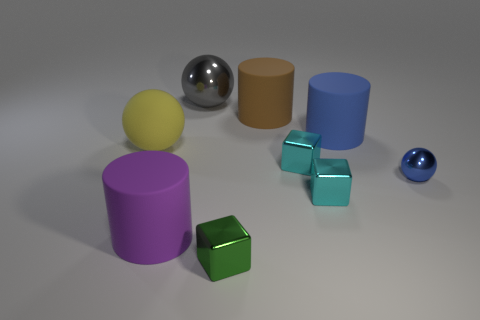There is a matte thing that is the same color as the tiny metallic sphere; what is its shape?
Make the answer very short. Cylinder. How many small things are the same shape as the big yellow thing?
Offer a very short reply. 1. How big is the green shiny block?
Provide a succinct answer. Small. There is a big gray ball; what number of large rubber objects are left of it?
Ensure brevity in your answer.  2. What size is the block that is behind the small blue metal object in front of the yellow object?
Your response must be concise. Small. There is a big matte thing that is in front of the yellow rubber object; does it have the same shape as the metal object that is right of the blue rubber object?
Your answer should be compact. No. What shape is the rubber object in front of the metal sphere in front of the gray ball?
Provide a short and direct response. Cylinder. What is the size of the sphere that is both on the right side of the yellow matte object and in front of the big gray metal sphere?
Your response must be concise. Small. Is the shape of the purple thing the same as the blue object on the left side of the small blue thing?
Your answer should be very brief. Yes. What is the size of the blue object that is the same shape as the big yellow matte thing?
Your answer should be compact. Small. 